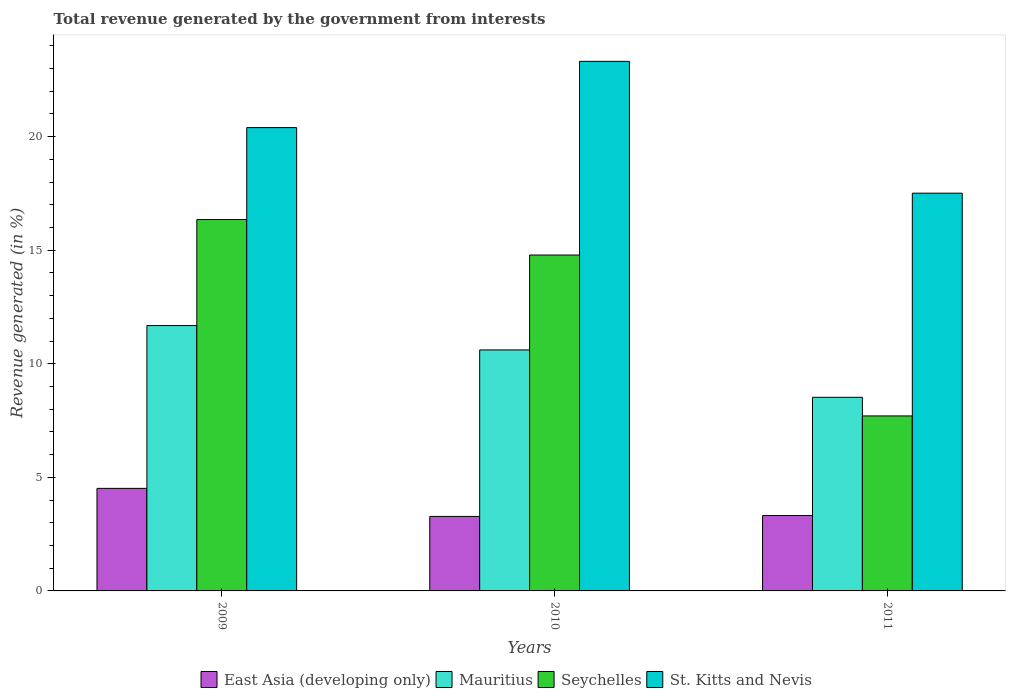How many different coloured bars are there?
Your response must be concise. 4. Are the number of bars per tick equal to the number of legend labels?
Ensure brevity in your answer.  Yes. What is the total revenue generated in St. Kitts and Nevis in 2009?
Make the answer very short. 20.4. Across all years, what is the maximum total revenue generated in East Asia (developing only)?
Keep it short and to the point. 4.52. Across all years, what is the minimum total revenue generated in Seychelles?
Your answer should be compact. 7.71. In which year was the total revenue generated in Mauritius maximum?
Keep it short and to the point. 2009. In which year was the total revenue generated in East Asia (developing only) minimum?
Offer a very short reply. 2010. What is the total total revenue generated in Mauritius in the graph?
Offer a very short reply. 30.82. What is the difference between the total revenue generated in St. Kitts and Nevis in 2010 and that in 2011?
Your answer should be very brief. 5.8. What is the difference between the total revenue generated in East Asia (developing only) in 2010 and the total revenue generated in Seychelles in 2009?
Offer a terse response. -13.07. What is the average total revenue generated in East Asia (developing only) per year?
Ensure brevity in your answer.  3.7. In the year 2009, what is the difference between the total revenue generated in Mauritius and total revenue generated in Seychelles?
Give a very brief answer. -4.67. In how many years, is the total revenue generated in Mauritius greater than 9 %?
Provide a succinct answer. 2. What is the ratio of the total revenue generated in St. Kitts and Nevis in 2009 to that in 2010?
Provide a succinct answer. 0.87. Is the total revenue generated in East Asia (developing only) in 2009 less than that in 2010?
Your answer should be very brief. No. Is the difference between the total revenue generated in Mauritius in 2009 and 2010 greater than the difference between the total revenue generated in Seychelles in 2009 and 2010?
Make the answer very short. No. What is the difference between the highest and the second highest total revenue generated in St. Kitts and Nevis?
Your response must be concise. 2.92. What is the difference between the highest and the lowest total revenue generated in Seychelles?
Keep it short and to the point. 8.65. In how many years, is the total revenue generated in Mauritius greater than the average total revenue generated in Mauritius taken over all years?
Provide a succinct answer. 2. Is it the case that in every year, the sum of the total revenue generated in Seychelles and total revenue generated in East Asia (developing only) is greater than the sum of total revenue generated in Mauritius and total revenue generated in St. Kitts and Nevis?
Keep it short and to the point. No. What does the 1st bar from the left in 2011 represents?
Ensure brevity in your answer.  East Asia (developing only). What does the 1st bar from the right in 2010 represents?
Ensure brevity in your answer.  St. Kitts and Nevis. Are all the bars in the graph horizontal?
Keep it short and to the point. No. Does the graph contain any zero values?
Your response must be concise. No. Where does the legend appear in the graph?
Your answer should be compact. Bottom center. What is the title of the graph?
Offer a very short reply. Total revenue generated by the government from interests. Does "United States" appear as one of the legend labels in the graph?
Your answer should be very brief. No. What is the label or title of the X-axis?
Offer a very short reply. Years. What is the label or title of the Y-axis?
Keep it short and to the point. Revenue generated (in %). What is the Revenue generated (in %) of East Asia (developing only) in 2009?
Provide a short and direct response. 4.52. What is the Revenue generated (in %) of Mauritius in 2009?
Your answer should be compact. 11.68. What is the Revenue generated (in %) of Seychelles in 2009?
Give a very brief answer. 16.35. What is the Revenue generated (in %) of St. Kitts and Nevis in 2009?
Ensure brevity in your answer.  20.4. What is the Revenue generated (in %) in East Asia (developing only) in 2010?
Offer a terse response. 3.28. What is the Revenue generated (in %) in Mauritius in 2010?
Offer a very short reply. 10.61. What is the Revenue generated (in %) of Seychelles in 2010?
Ensure brevity in your answer.  14.79. What is the Revenue generated (in %) in St. Kitts and Nevis in 2010?
Your response must be concise. 23.32. What is the Revenue generated (in %) of East Asia (developing only) in 2011?
Provide a short and direct response. 3.32. What is the Revenue generated (in %) of Mauritius in 2011?
Make the answer very short. 8.53. What is the Revenue generated (in %) in Seychelles in 2011?
Keep it short and to the point. 7.71. What is the Revenue generated (in %) of St. Kitts and Nevis in 2011?
Provide a succinct answer. 17.51. Across all years, what is the maximum Revenue generated (in %) of East Asia (developing only)?
Make the answer very short. 4.52. Across all years, what is the maximum Revenue generated (in %) of Mauritius?
Make the answer very short. 11.68. Across all years, what is the maximum Revenue generated (in %) of Seychelles?
Offer a very short reply. 16.35. Across all years, what is the maximum Revenue generated (in %) of St. Kitts and Nevis?
Your answer should be compact. 23.32. Across all years, what is the minimum Revenue generated (in %) in East Asia (developing only)?
Keep it short and to the point. 3.28. Across all years, what is the minimum Revenue generated (in %) of Mauritius?
Provide a short and direct response. 8.53. Across all years, what is the minimum Revenue generated (in %) of Seychelles?
Make the answer very short. 7.71. Across all years, what is the minimum Revenue generated (in %) of St. Kitts and Nevis?
Provide a short and direct response. 17.51. What is the total Revenue generated (in %) in East Asia (developing only) in the graph?
Provide a short and direct response. 11.11. What is the total Revenue generated (in %) in Mauritius in the graph?
Provide a succinct answer. 30.82. What is the total Revenue generated (in %) in Seychelles in the graph?
Offer a terse response. 38.85. What is the total Revenue generated (in %) of St. Kitts and Nevis in the graph?
Your answer should be very brief. 61.23. What is the difference between the Revenue generated (in %) of East Asia (developing only) in 2009 and that in 2010?
Your response must be concise. 1.24. What is the difference between the Revenue generated (in %) of Mauritius in 2009 and that in 2010?
Your answer should be very brief. 1.07. What is the difference between the Revenue generated (in %) of Seychelles in 2009 and that in 2010?
Offer a very short reply. 1.56. What is the difference between the Revenue generated (in %) in St. Kitts and Nevis in 2009 and that in 2010?
Offer a terse response. -2.92. What is the difference between the Revenue generated (in %) of East Asia (developing only) in 2009 and that in 2011?
Provide a succinct answer. 1.2. What is the difference between the Revenue generated (in %) in Mauritius in 2009 and that in 2011?
Your response must be concise. 3.16. What is the difference between the Revenue generated (in %) of Seychelles in 2009 and that in 2011?
Provide a succinct answer. 8.65. What is the difference between the Revenue generated (in %) in St. Kitts and Nevis in 2009 and that in 2011?
Give a very brief answer. 2.89. What is the difference between the Revenue generated (in %) in East Asia (developing only) in 2010 and that in 2011?
Your answer should be compact. -0.04. What is the difference between the Revenue generated (in %) of Mauritius in 2010 and that in 2011?
Your answer should be compact. 2.09. What is the difference between the Revenue generated (in %) in Seychelles in 2010 and that in 2011?
Your answer should be very brief. 7.09. What is the difference between the Revenue generated (in %) of St. Kitts and Nevis in 2010 and that in 2011?
Offer a very short reply. 5.8. What is the difference between the Revenue generated (in %) of East Asia (developing only) in 2009 and the Revenue generated (in %) of Mauritius in 2010?
Your answer should be compact. -6.1. What is the difference between the Revenue generated (in %) in East Asia (developing only) in 2009 and the Revenue generated (in %) in Seychelles in 2010?
Provide a succinct answer. -10.28. What is the difference between the Revenue generated (in %) of East Asia (developing only) in 2009 and the Revenue generated (in %) of St. Kitts and Nevis in 2010?
Your answer should be compact. -18.8. What is the difference between the Revenue generated (in %) in Mauritius in 2009 and the Revenue generated (in %) in Seychelles in 2010?
Make the answer very short. -3.11. What is the difference between the Revenue generated (in %) of Mauritius in 2009 and the Revenue generated (in %) of St. Kitts and Nevis in 2010?
Your response must be concise. -11.63. What is the difference between the Revenue generated (in %) of Seychelles in 2009 and the Revenue generated (in %) of St. Kitts and Nevis in 2010?
Your answer should be compact. -6.97. What is the difference between the Revenue generated (in %) in East Asia (developing only) in 2009 and the Revenue generated (in %) in Mauritius in 2011?
Keep it short and to the point. -4.01. What is the difference between the Revenue generated (in %) of East Asia (developing only) in 2009 and the Revenue generated (in %) of Seychelles in 2011?
Provide a short and direct response. -3.19. What is the difference between the Revenue generated (in %) in East Asia (developing only) in 2009 and the Revenue generated (in %) in St. Kitts and Nevis in 2011?
Offer a very short reply. -13. What is the difference between the Revenue generated (in %) of Mauritius in 2009 and the Revenue generated (in %) of Seychelles in 2011?
Provide a succinct answer. 3.98. What is the difference between the Revenue generated (in %) in Mauritius in 2009 and the Revenue generated (in %) in St. Kitts and Nevis in 2011?
Keep it short and to the point. -5.83. What is the difference between the Revenue generated (in %) in Seychelles in 2009 and the Revenue generated (in %) in St. Kitts and Nevis in 2011?
Ensure brevity in your answer.  -1.16. What is the difference between the Revenue generated (in %) in East Asia (developing only) in 2010 and the Revenue generated (in %) in Mauritius in 2011?
Offer a very short reply. -5.25. What is the difference between the Revenue generated (in %) of East Asia (developing only) in 2010 and the Revenue generated (in %) of Seychelles in 2011?
Offer a terse response. -4.43. What is the difference between the Revenue generated (in %) of East Asia (developing only) in 2010 and the Revenue generated (in %) of St. Kitts and Nevis in 2011?
Your answer should be very brief. -14.23. What is the difference between the Revenue generated (in %) in Mauritius in 2010 and the Revenue generated (in %) in Seychelles in 2011?
Offer a terse response. 2.91. What is the difference between the Revenue generated (in %) in Mauritius in 2010 and the Revenue generated (in %) in St. Kitts and Nevis in 2011?
Make the answer very short. -6.9. What is the difference between the Revenue generated (in %) of Seychelles in 2010 and the Revenue generated (in %) of St. Kitts and Nevis in 2011?
Offer a very short reply. -2.72. What is the average Revenue generated (in %) in East Asia (developing only) per year?
Ensure brevity in your answer.  3.7. What is the average Revenue generated (in %) in Mauritius per year?
Keep it short and to the point. 10.27. What is the average Revenue generated (in %) of Seychelles per year?
Offer a very short reply. 12.95. What is the average Revenue generated (in %) of St. Kitts and Nevis per year?
Ensure brevity in your answer.  20.41. In the year 2009, what is the difference between the Revenue generated (in %) in East Asia (developing only) and Revenue generated (in %) in Mauritius?
Provide a succinct answer. -7.17. In the year 2009, what is the difference between the Revenue generated (in %) in East Asia (developing only) and Revenue generated (in %) in Seychelles?
Give a very brief answer. -11.84. In the year 2009, what is the difference between the Revenue generated (in %) of East Asia (developing only) and Revenue generated (in %) of St. Kitts and Nevis?
Ensure brevity in your answer.  -15.89. In the year 2009, what is the difference between the Revenue generated (in %) of Mauritius and Revenue generated (in %) of Seychelles?
Your answer should be very brief. -4.67. In the year 2009, what is the difference between the Revenue generated (in %) in Mauritius and Revenue generated (in %) in St. Kitts and Nevis?
Offer a very short reply. -8.72. In the year 2009, what is the difference between the Revenue generated (in %) of Seychelles and Revenue generated (in %) of St. Kitts and Nevis?
Your response must be concise. -4.05. In the year 2010, what is the difference between the Revenue generated (in %) in East Asia (developing only) and Revenue generated (in %) in Mauritius?
Your answer should be compact. -7.33. In the year 2010, what is the difference between the Revenue generated (in %) of East Asia (developing only) and Revenue generated (in %) of Seychelles?
Offer a terse response. -11.51. In the year 2010, what is the difference between the Revenue generated (in %) in East Asia (developing only) and Revenue generated (in %) in St. Kitts and Nevis?
Offer a terse response. -20.04. In the year 2010, what is the difference between the Revenue generated (in %) of Mauritius and Revenue generated (in %) of Seychelles?
Ensure brevity in your answer.  -4.18. In the year 2010, what is the difference between the Revenue generated (in %) in Mauritius and Revenue generated (in %) in St. Kitts and Nevis?
Provide a short and direct response. -12.71. In the year 2010, what is the difference between the Revenue generated (in %) in Seychelles and Revenue generated (in %) in St. Kitts and Nevis?
Offer a very short reply. -8.53. In the year 2011, what is the difference between the Revenue generated (in %) in East Asia (developing only) and Revenue generated (in %) in Mauritius?
Your response must be concise. -5.21. In the year 2011, what is the difference between the Revenue generated (in %) of East Asia (developing only) and Revenue generated (in %) of Seychelles?
Provide a succinct answer. -4.39. In the year 2011, what is the difference between the Revenue generated (in %) in East Asia (developing only) and Revenue generated (in %) in St. Kitts and Nevis?
Your answer should be compact. -14.19. In the year 2011, what is the difference between the Revenue generated (in %) of Mauritius and Revenue generated (in %) of Seychelles?
Make the answer very short. 0.82. In the year 2011, what is the difference between the Revenue generated (in %) in Mauritius and Revenue generated (in %) in St. Kitts and Nevis?
Provide a short and direct response. -8.99. In the year 2011, what is the difference between the Revenue generated (in %) in Seychelles and Revenue generated (in %) in St. Kitts and Nevis?
Your answer should be compact. -9.81. What is the ratio of the Revenue generated (in %) in East Asia (developing only) in 2009 to that in 2010?
Keep it short and to the point. 1.38. What is the ratio of the Revenue generated (in %) in Mauritius in 2009 to that in 2010?
Give a very brief answer. 1.1. What is the ratio of the Revenue generated (in %) of Seychelles in 2009 to that in 2010?
Make the answer very short. 1.11. What is the ratio of the Revenue generated (in %) of St. Kitts and Nevis in 2009 to that in 2010?
Your answer should be very brief. 0.87. What is the ratio of the Revenue generated (in %) of East Asia (developing only) in 2009 to that in 2011?
Offer a terse response. 1.36. What is the ratio of the Revenue generated (in %) of Mauritius in 2009 to that in 2011?
Give a very brief answer. 1.37. What is the ratio of the Revenue generated (in %) of Seychelles in 2009 to that in 2011?
Your answer should be very brief. 2.12. What is the ratio of the Revenue generated (in %) in St. Kitts and Nevis in 2009 to that in 2011?
Make the answer very short. 1.16. What is the ratio of the Revenue generated (in %) in Mauritius in 2010 to that in 2011?
Provide a short and direct response. 1.24. What is the ratio of the Revenue generated (in %) in Seychelles in 2010 to that in 2011?
Your answer should be compact. 1.92. What is the ratio of the Revenue generated (in %) of St. Kitts and Nevis in 2010 to that in 2011?
Offer a very short reply. 1.33. What is the difference between the highest and the second highest Revenue generated (in %) in East Asia (developing only)?
Provide a short and direct response. 1.2. What is the difference between the highest and the second highest Revenue generated (in %) of Mauritius?
Your answer should be very brief. 1.07. What is the difference between the highest and the second highest Revenue generated (in %) of Seychelles?
Keep it short and to the point. 1.56. What is the difference between the highest and the second highest Revenue generated (in %) in St. Kitts and Nevis?
Make the answer very short. 2.92. What is the difference between the highest and the lowest Revenue generated (in %) of East Asia (developing only)?
Offer a terse response. 1.24. What is the difference between the highest and the lowest Revenue generated (in %) of Mauritius?
Make the answer very short. 3.16. What is the difference between the highest and the lowest Revenue generated (in %) in Seychelles?
Your answer should be compact. 8.65. What is the difference between the highest and the lowest Revenue generated (in %) in St. Kitts and Nevis?
Keep it short and to the point. 5.8. 